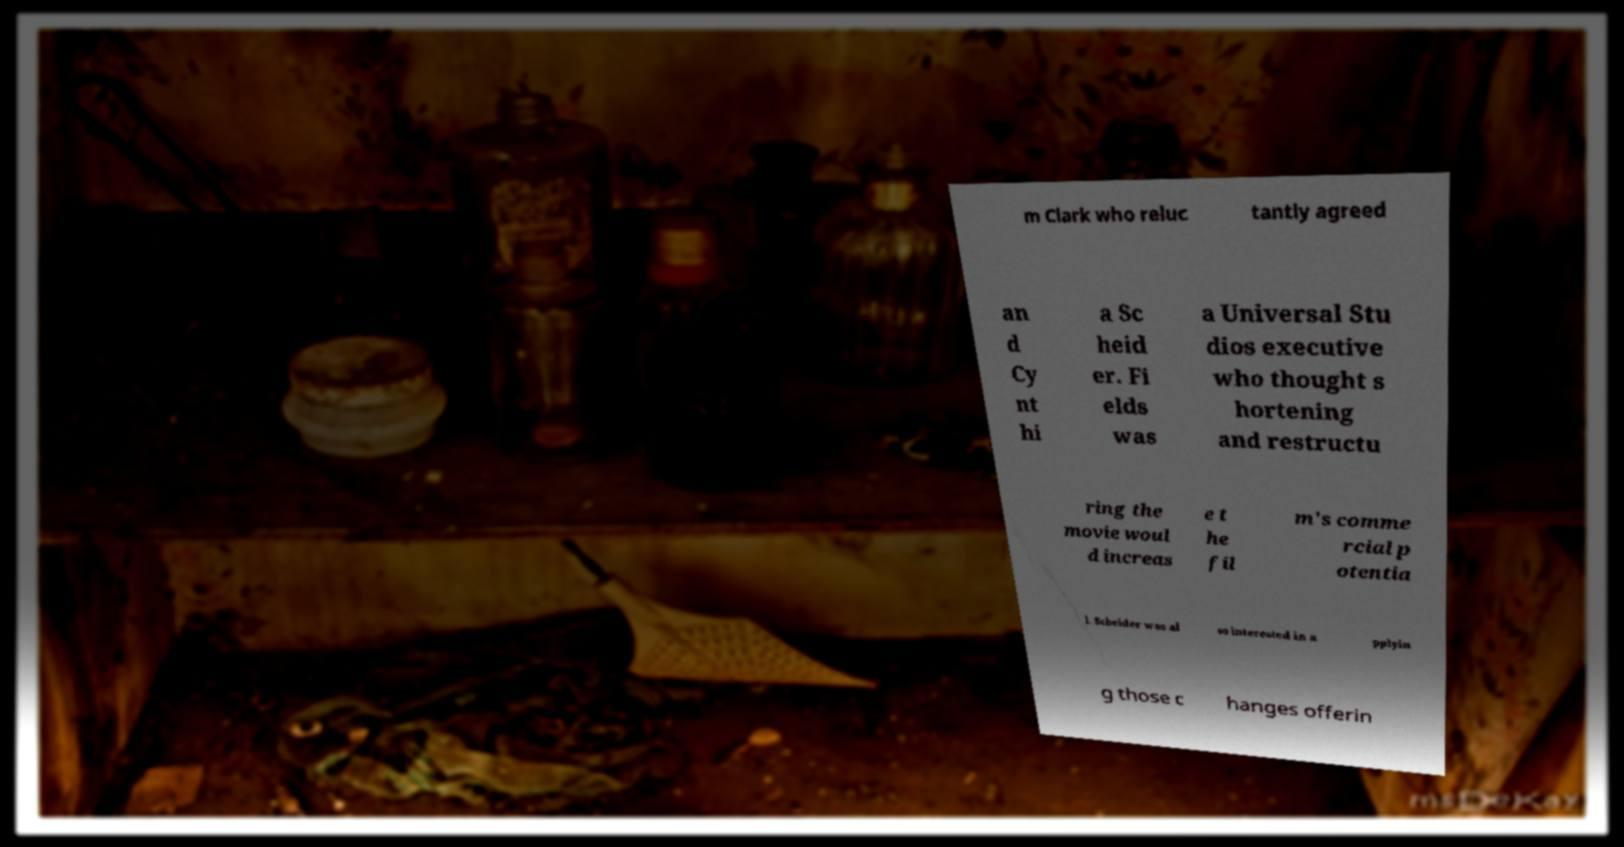Could you assist in decoding the text presented in this image and type it out clearly? m Clark who reluc tantly agreed an d Cy nt hi a Sc heid er. Fi elds was a Universal Stu dios executive who thought s hortening and restructu ring the movie woul d increas e t he fil m's comme rcial p otentia l. Scheider was al so interested in a pplyin g those c hanges offerin 